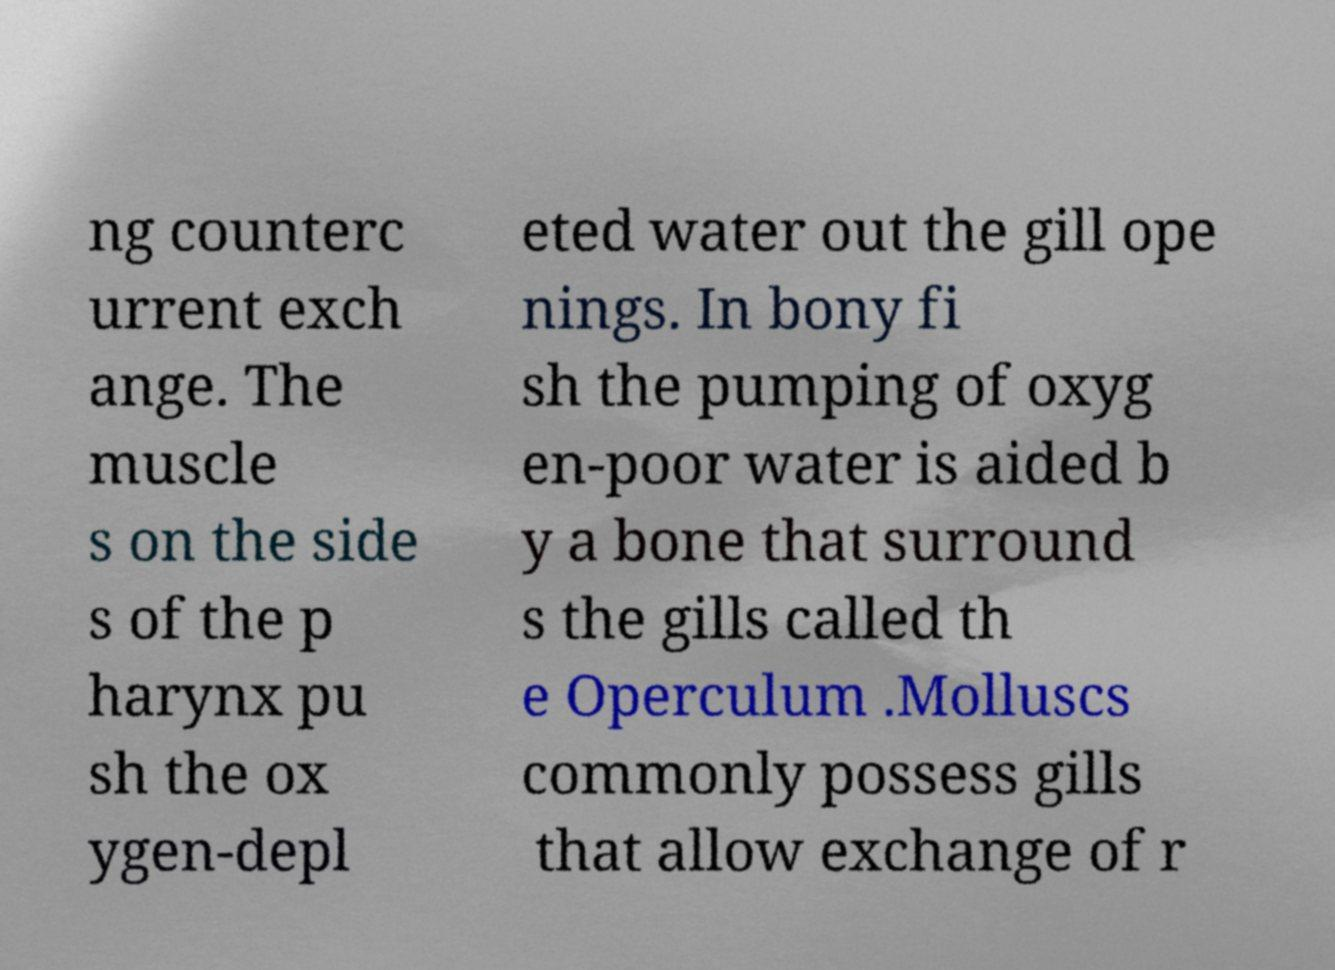Can you read and provide the text displayed in the image?This photo seems to have some interesting text. Can you extract and type it out for me? ng counterc urrent exch ange. The muscle s on the side s of the p harynx pu sh the ox ygen-depl eted water out the gill ope nings. In bony fi sh the pumping of oxyg en-poor water is aided b y a bone that surround s the gills called th e Operculum .Molluscs commonly possess gills that allow exchange of r 